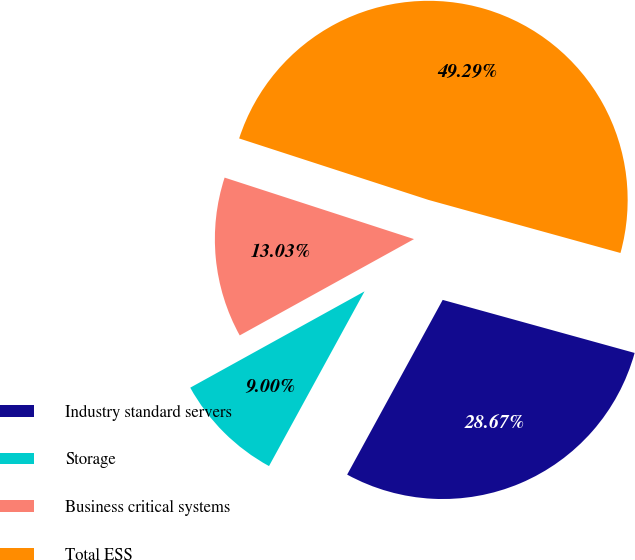Convert chart. <chart><loc_0><loc_0><loc_500><loc_500><pie_chart><fcel>Industry standard servers<fcel>Storage<fcel>Business critical systems<fcel>Total ESS<nl><fcel>28.67%<fcel>9.0%<fcel>13.03%<fcel>49.29%<nl></chart> 